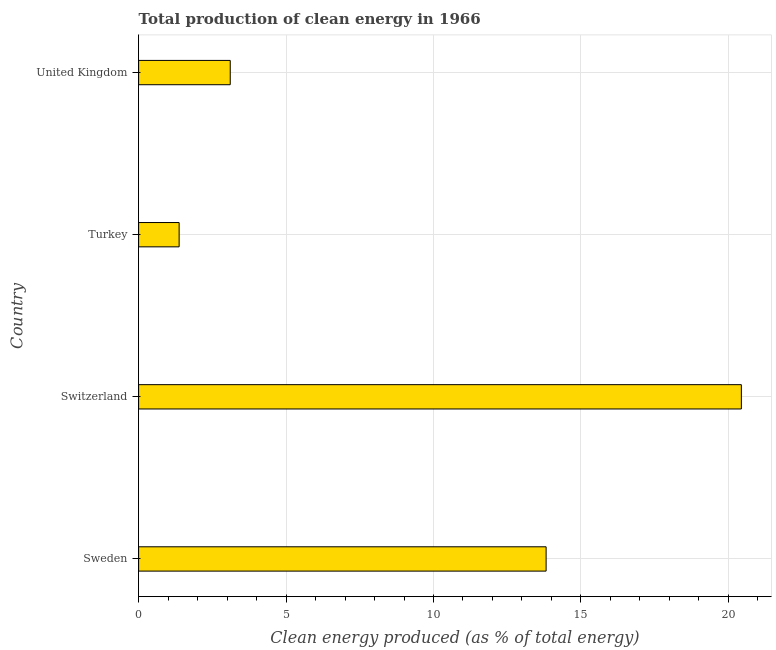What is the title of the graph?
Offer a very short reply. Total production of clean energy in 1966. What is the label or title of the X-axis?
Make the answer very short. Clean energy produced (as % of total energy). What is the production of clean energy in Switzerland?
Offer a very short reply. 20.44. Across all countries, what is the maximum production of clean energy?
Make the answer very short. 20.44. Across all countries, what is the minimum production of clean energy?
Provide a succinct answer. 1.37. In which country was the production of clean energy maximum?
Offer a terse response. Switzerland. In which country was the production of clean energy minimum?
Keep it short and to the point. Turkey. What is the sum of the production of clean energy?
Offer a terse response. 38.74. What is the difference between the production of clean energy in Sweden and Switzerland?
Your answer should be very brief. -6.62. What is the average production of clean energy per country?
Provide a succinct answer. 9.69. What is the median production of clean energy?
Your response must be concise. 8.46. What is the ratio of the production of clean energy in Switzerland to that in United Kingdom?
Provide a short and direct response. 6.58. Is the production of clean energy in Sweden less than that in Turkey?
Give a very brief answer. No. What is the difference between the highest and the second highest production of clean energy?
Keep it short and to the point. 6.62. Is the sum of the production of clean energy in Sweden and Turkey greater than the maximum production of clean energy across all countries?
Provide a short and direct response. No. What is the difference between the highest and the lowest production of clean energy?
Your answer should be very brief. 19.07. How many countries are there in the graph?
Provide a succinct answer. 4. What is the Clean energy produced (as % of total energy) in Sweden?
Give a very brief answer. 13.82. What is the Clean energy produced (as % of total energy) in Switzerland?
Offer a very short reply. 20.44. What is the Clean energy produced (as % of total energy) in Turkey?
Offer a terse response. 1.37. What is the Clean energy produced (as % of total energy) in United Kingdom?
Offer a terse response. 3.11. What is the difference between the Clean energy produced (as % of total energy) in Sweden and Switzerland?
Your answer should be compact. -6.62. What is the difference between the Clean energy produced (as % of total energy) in Sweden and Turkey?
Offer a terse response. 12.45. What is the difference between the Clean energy produced (as % of total energy) in Sweden and United Kingdom?
Offer a terse response. 10.71. What is the difference between the Clean energy produced (as % of total energy) in Switzerland and Turkey?
Your response must be concise. 19.07. What is the difference between the Clean energy produced (as % of total energy) in Switzerland and United Kingdom?
Provide a succinct answer. 17.33. What is the difference between the Clean energy produced (as % of total energy) in Turkey and United Kingdom?
Provide a short and direct response. -1.73. What is the ratio of the Clean energy produced (as % of total energy) in Sweden to that in Switzerland?
Your answer should be very brief. 0.68. What is the ratio of the Clean energy produced (as % of total energy) in Sweden to that in Turkey?
Your response must be concise. 10.06. What is the ratio of the Clean energy produced (as % of total energy) in Sweden to that in United Kingdom?
Provide a succinct answer. 4.45. What is the ratio of the Clean energy produced (as % of total energy) in Switzerland to that in Turkey?
Your answer should be compact. 14.88. What is the ratio of the Clean energy produced (as % of total energy) in Switzerland to that in United Kingdom?
Your response must be concise. 6.58. What is the ratio of the Clean energy produced (as % of total energy) in Turkey to that in United Kingdom?
Provide a short and direct response. 0.44. 